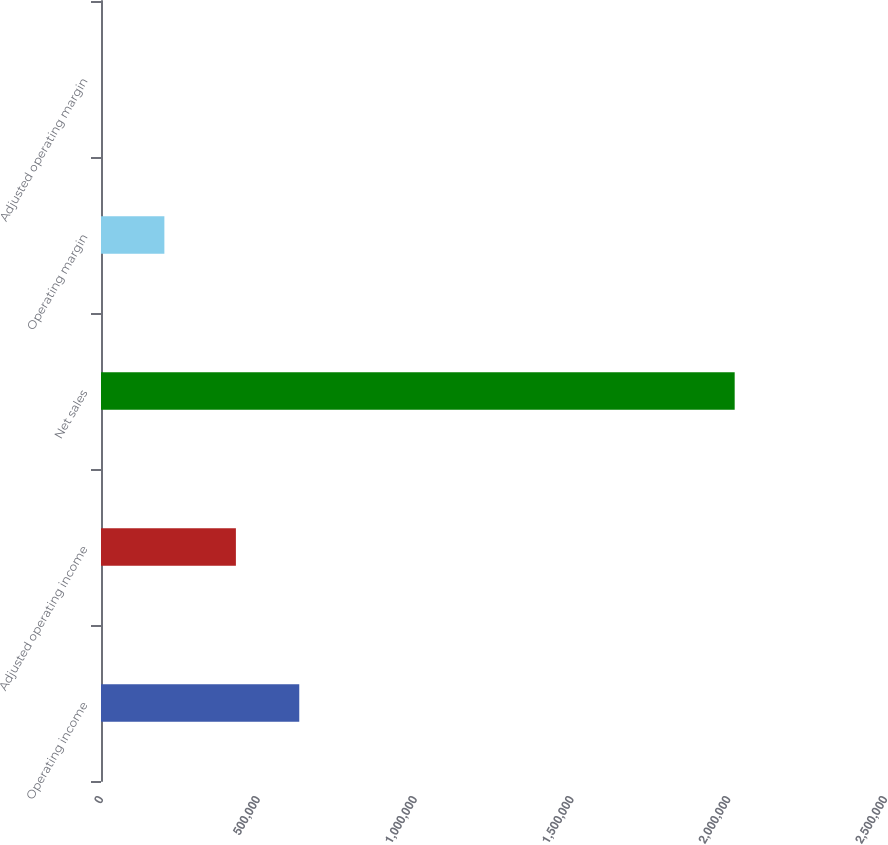Convert chart. <chart><loc_0><loc_0><loc_500><loc_500><bar_chart><fcel>Operating income<fcel>Adjusted operating income<fcel>Net sales<fcel>Operating margin<fcel>Adjusted operating margin<nl><fcel>632224<fcel>430159<fcel>2.02067e+06<fcel>202086<fcel>21.3<nl></chart> 